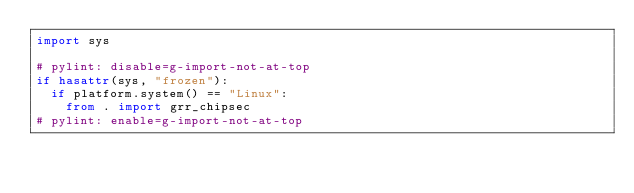Convert code to text. <code><loc_0><loc_0><loc_500><loc_500><_Python_>import sys

# pylint: disable=g-import-not-at-top
if hasattr(sys, "frozen"):
  if platform.system() == "Linux":
    from . import grr_chipsec
# pylint: enable=g-import-not-at-top
</code> 